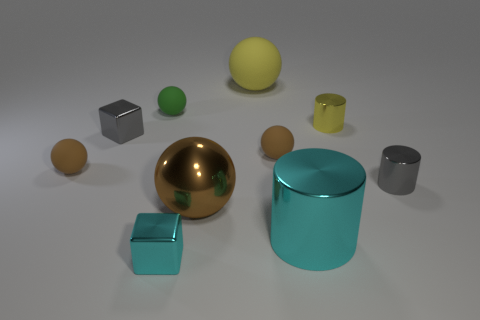Subtract all purple cylinders. How many brown spheres are left? 3 Subtract 1 spheres. How many spheres are left? 4 Subtract all yellow spheres. How many spheres are left? 4 Subtract all big metallic spheres. How many spheres are left? 4 Subtract all red balls. Subtract all purple cylinders. How many balls are left? 5 Subtract all cubes. How many objects are left? 8 Subtract 0 purple cylinders. How many objects are left? 10 Subtract all tiny gray shiny cubes. Subtract all small cyan shiny cubes. How many objects are left? 8 Add 7 tiny matte things. How many tiny matte things are left? 10 Add 2 tiny green matte cylinders. How many tiny green matte cylinders exist? 2 